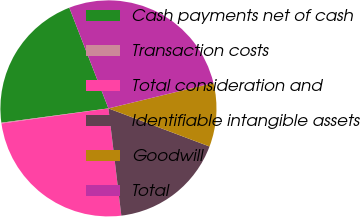Convert chart. <chart><loc_0><loc_0><loc_500><loc_500><pie_chart><fcel>Cash payments net of cash<fcel>Transaction costs<fcel>Total consideration and<fcel>Identifiable intangible assets<fcel>Goodwill<fcel>Total<nl><fcel>21.22%<fcel>0.12%<fcel>24.67%<fcel>17.36%<fcel>9.52%<fcel>27.12%<nl></chart> 